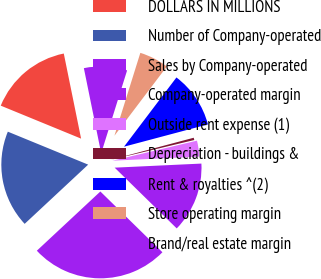<chart> <loc_0><loc_0><loc_500><loc_500><pie_chart><fcel>DOLLARS IN MILLIONS<fcel>Number of Company-operated<fcel>Sales by Company-operated<fcel>Company-operated margin<fcel>Outside rent expense (1)<fcel>Depreciation - buildings &<fcel>Rent & royalties ^(2)<fcel>Store operating margin<fcel>Brand/real estate margin<nl><fcel>15.61%<fcel>18.14%<fcel>25.73%<fcel>13.08%<fcel>2.96%<fcel>0.43%<fcel>10.55%<fcel>5.49%<fcel>8.02%<nl></chart> 